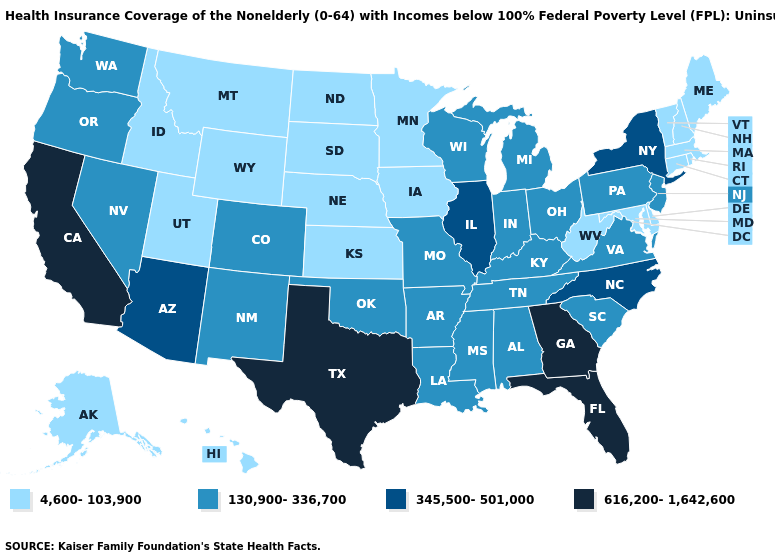Among the states that border Florida , does Georgia have the lowest value?
Answer briefly. No. What is the value of California?
Concise answer only. 616,200-1,642,600. What is the lowest value in states that border Washington?
Keep it brief. 4,600-103,900. Does Arkansas have a higher value than Alaska?
Write a very short answer. Yes. What is the value of Ohio?
Be succinct. 130,900-336,700. What is the highest value in the West ?
Short answer required. 616,200-1,642,600. Which states hav the highest value in the Northeast?
Answer briefly. New York. Name the states that have a value in the range 345,500-501,000?
Be succinct. Arizona, Illinois, New York, North Carolina. What is the highest value in the USA?
Give a very brief answer. 616,200-1,642,600. Among the states that border California , does Oregon have the highest value?
Give a very brief answer. No. Does Virginia have the same value as New Mexico?
Answer briefly. Yes. Does Mississippi have a lower value than Arkansas?
Short answer required. No. Is the legend a continuous bar?
Concise answer only. No. What is the lowest value in the USA?
Answer briefly. 4,600-103,900. 